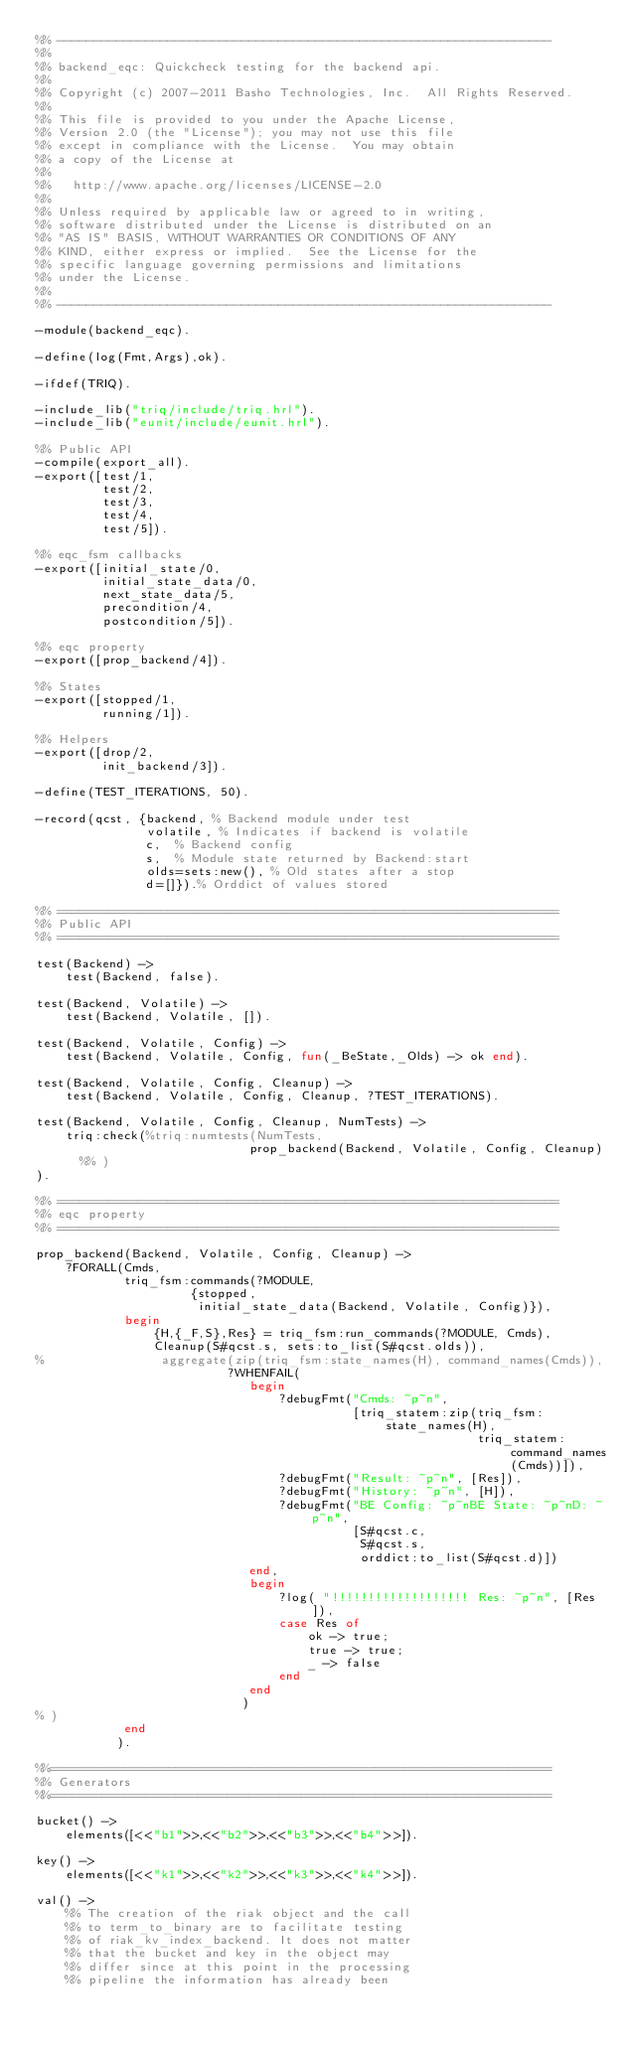<code> <loc_0><loc_0><loc_500><loc_500><_Erlang_>%% -------------------------------------------------------------------
%%
%% backend_eqc: Quickcheck testing for the backend api.
%%
%% Copyright (c) 2007-2011 Basho Technologies, Inc.  All Rights Reserved.
%%
%% This file is provided to you under the Apache License,
%% Version 2.0 (the "License"); you may not use this file
%% except in compliance with the License.  You may obtain
%% a copy of the License at
%%
%%   http://www.apache.org/licenses/LICENSE-2.0
%%
%% Unless required by applicable law or agreed to in writing,
%% software distributed under the License is distributed on an
%% "AS IS" BASIS, WITHOUT WARRANTIES OR CONDITIONS OF ANY
%% KIND, either express or implied.  See the License for the
%% specific language governing permissions and limitations
%% under the License.
%%
%% -------------------------------------------------------------------

-module(backend_eqc).

-define(log(Fmt,Args),ok).

-ifdef(TRIQ).

-include_lib("triq/include/triq.hrl").
-include_lib("eunit/include/eunit.hrl").

%% Public API
-compile(export_all).
-export([test/1,
         test/2,
         test/3,
         test/4,
         test/5]).

%% eqc_fsm callbacks
-export([initial_state/0,
         initial_state_data/0,
         next_state_data/5,
         precondition/4,
         postcondition/5]).

%% eqc property
-export([prop_backend/4]).

%% States
-export([stopped/1,
         running/1]).

%% Helpers
-export([drop/2,
         init_backend/3]).

-define(TEST_ITERATIONS, 50).

-record(qcst, {backend, % Backend module under test
               volatile, % Indicates if backend is volatile
               c,  % Backend config
               s,  % Module state returned by Backend:start
               olds=sets:new(), % Old states after a stop
               d=[]}).% Orddict of values stored

%% ====================================================================
%% Public API
%% ====================================================================

test(Backend) ->
    test(Backend, false).

test(Backend, Volatile) ->
    test(Backend, Volatile, []).

test(Backend, Volatile, Config) ->
    test(Backend, Volatile, Config, fun(_BeState,_Olds) -> ok end).

test(Backend, Volatile, Config, Cleanup) ->
    test(Backend, Volatile, Config, Cleanup, ?TEST_ITERATIONS).

test(Backend, Volatile, Config, Cleanup, NumTests) ->
    triq:check(%triq:numtests(NumTests,
                             prop_backend(Backend, Volatile, Config, Cleanup)
      %% )
).

%% ====================================================================
%% eqc property
%% ====================================================================

prop_backend(Backend, Volatile, Config, Cleanup) ->
    ?FORALL(Cmds,
            triq_fsm:commands(?MODULE,
                     {stopped,
                      initial_state_data(Backend, Volatile, Config)}),
            begin
                {H,{_F,S},Res} = triq_fsm:run_commands(?MODULE, Cmds),
                Cleanup(S#qcst.s, sets:to_list(S#qcst.olds)),
%                aggregate(zip(triq_fsm:state_names(H), command_names(Cmds)),
                          ?WHENFAIL(
                             begin
                                 ?debugFmt("Cmds: ~p~n",
                                           [triq_statem:zip(triq_fsm:state_names(H),
                                                            triq_statem:command_names(Cmds))]),
                                 ?debugFmt("Result: ~p~n", [Res]),
                                 ?debugFmt("History: ~p~n", [H]),
                                 ?debugFmt("BE Config: ~p~nBE State: ~p~nD: ~p~n",
                                           [S#qcst.c,
                                            S#qcst.s,
                                            orddict:to_list(S#qcst.d)])
                             end,
                             begin
                                 ?log( "!!!!!!!!!!!!!!!!!!! Res: ~p~n", [Res]),
                                 case Res of
                                     ok -> true;
                                     true -> true;
                                     _ -> false
                                 end
                             end
                            )
% )
            end
           ).

%%====================================================================
%% Generators
%%====================================================================

bucket() ->
    elements([<<"b1">>,<<"b2">>,<<"b3">>,<<"b4">>]).

key() ->
    elements([<<"k1">>,<<"k2">>,<<"k3">>,<<"k4">>]).

val() ->
    %% The creation of the riak object and the call
    %% to term_to_binary are to facilitate testing
    %% of riak_kv_index_backend. It does not matter
    %% that the bucket and key in the object may
    %% differ since at this point in the processing
    %% pipeline the information has already been</code> 